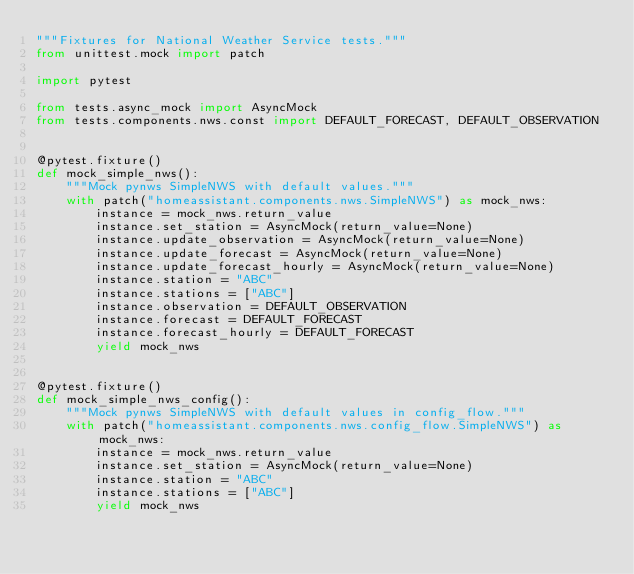<code> <loc_0><loc_0><loc_500><loc_500><_Python_>"""Fixtures for National Weather Service tests."""
from unittest.mock import patch

import pytest

from tests.async_mock import AsyncMock
from tests.components.nws.const import DEFAULT_FORECAST, DEFAULT_OBSERVATION


@pytest.fixture()
def mock_simple_nws():
    """Mock pynws SimpleNWS with default values."""
    with patch("homeassistant.components.nws.SimpleNWS") as mock_nws:
        instance = mock_nws.return_value
        instance.set_station = AsyncMock(return_value=None)
        instance.update_observation = AsyncMock(return_value=None)
        instance.update_forecast = AsyncMock(return_value=None)
        instance.update_forecast_hourly = AsyncMock(return_value=None)
        instance.station = "ABC"
        instance.stations = ["ABC"]
        instance.observation = DEFAULT_OBSERVATION
        instance.forecast = DEFAULT_FORECAST
        instance.forecast_hourly = DEFAULT_FORECAST
        yield mock_nws


@pytest.fixture()
def mock_simple_nws_config():
    """Mock pynws SimpleNWS with default values in config_flow."""
    with patch("homeassistant.components.nws.config_flow.SimpleNWS") as mock_nws:
        instance = mock_nws.return_value
        instance.set_station = AsyncMock(return_value=None)
        instance.station = "ABC"
        instance.stations = ["ABC"]
        yield mock_nws
</code> 